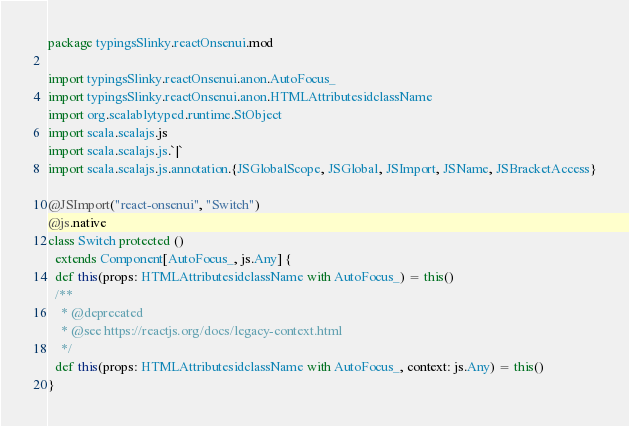Convert code to text. <code><loc_0><loc_0><loc_500><loc_500><_Scala_>package typingsSlinky.reactOnsenui.mod

import typingsSlinky.reactOnsenui.anon.AutoFocus_
import typingsSlinky.reactOnsenui.anon.HTMLAttributesidclassName
import org.scalablytyped.runtime.StObject
import scala.scalajs.js
import scala.scalajs.js.`|`
import scala.scalajs.js.annotation.{JSGlobalScope, JSGlobal, JSImport, JSName, JSBracketAccess}

@JSImport("react-onsenui", "Switch")
@js.native
class Switch protected ()
  extends Component[AutoFocus_, js.Any] {
  def this(props: HTMLAttributesidclassName with AutoFocus_) = this()
  /**
    * @deprecated
    * @see https://reactjs.org/docs/legacy-context.html
    */
  def this(props: HTMLAttributesidclassName with AutoFocus_, context: js.Any) = this()
}
</code> 